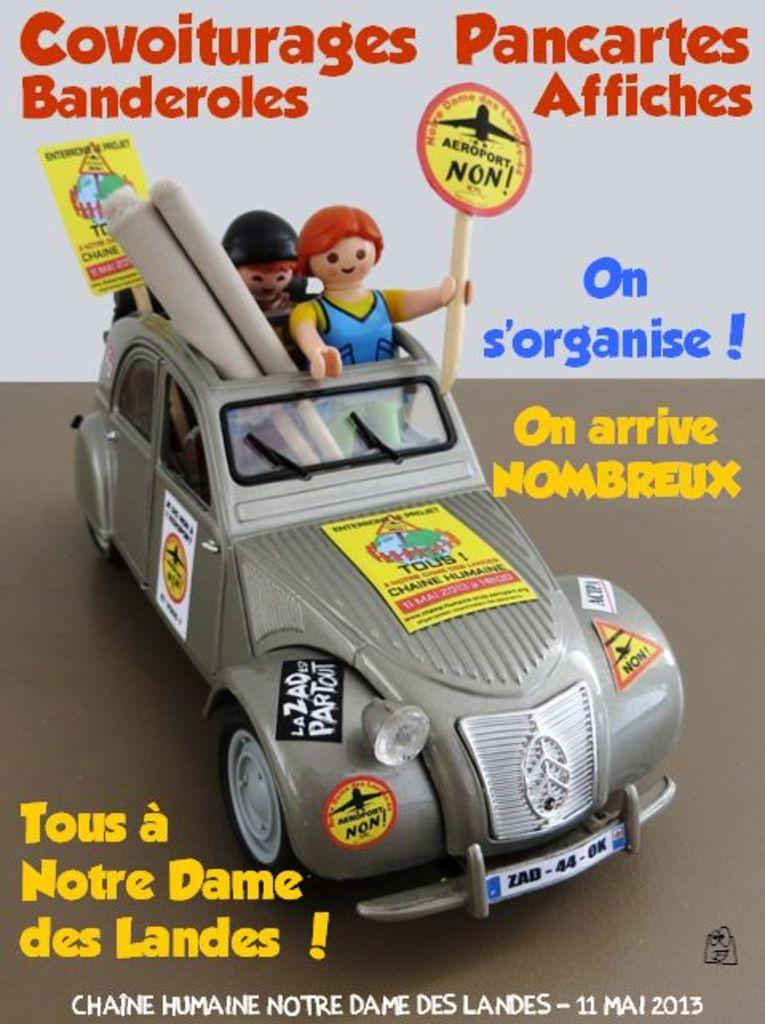What is located in the center of the image? There are toys in the center of the image. What can be seen written on the top of the image? There is text written on the top of the image. What is written in the center of the image? There is text written in the center of the image. What can be seen written on the bottom side of the image? There is text written on the bottom side of the image. What type of butter is being used to lubricate the gate in the image? There is no gate or butter present in the image. What point is being made with the text in the image? The image does not convey a specific point or message; it only shows toys and text. 